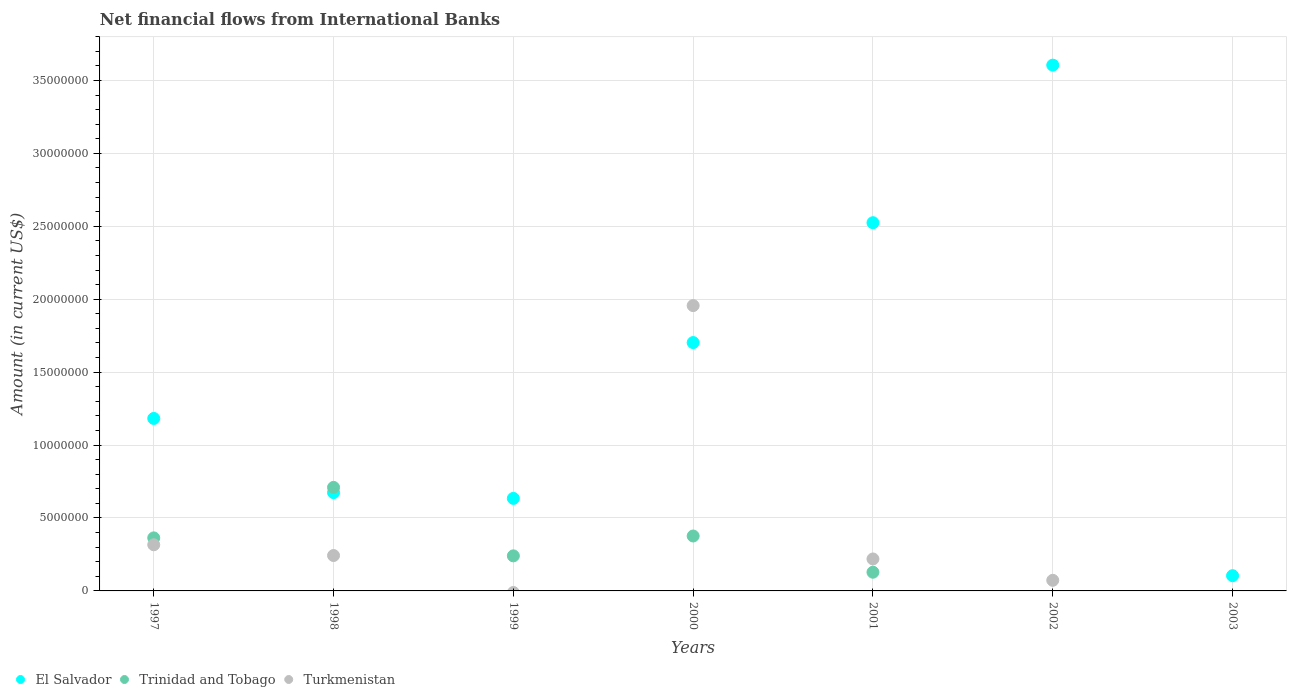Is the number of dotlines equal to the number of legend labels?
Keep it short and to the point. No. What is the net financial aid flows in Trinidad and Tobago in 1999?
Offer a terse response. 2.40e+06. Across all years, what is the maximum net financial aid flows in El Salvador?
Your response must be concise. 3.60e+07. In which year was the net financial aid flows in Trinidad and Tobago maximum?
Provide a succinct answer. 1998. What is the total net financial aid flows in Trinidad and Tobago in the graph?
Your answer should be very brief. 1.82e+07. What is the difference between the net financial aid flows in El Salvador in 2000 and that in 2003?
Your answer should be very brief. 1.60e+07. What is the difference between the net financial aid flows in Turkmenistan in 1999 and the net financial aid flows in Trinidad and Tobago in 2001?
Provide a succinct answer. -1.28e+06. What is the average net financial aid flows in Trinidad and Tobago per year?
Your answer should be very brief. 2.60e+06. In the year 1997, what is the difference between the net financial aid flows in El Salvador and net financial aid flows in Turkmenistan?
Ensure brevity in your answer.  8.66e+06. What is the ratio of the net financial aid flows in El Salvador in 2001 to that in 2003?
Your answer should be very brief. 24.18. Is the net financial aid flows in El Salvador in 1999 less than that in 2001?
Give a very brief answer. Yes. What is the difference between the highest and the second highest net financial aid flows in El Salvador?
Offer a very short reply. 1.08e+07. What is the difference between the highest and the lowest net financial aid flows in Turkmenistan?
Provide a short and direct response. 1.96e+07. In how many years, is the net financial aid flows in Turkmenistan greater than the average net financial aid flows in Turkmenistan taken over all years?
Your answer should be compact. 1. Where does the legend appear in the graph?
Give a very brief answer. Bottom left. How are the legend labels stacked?
Keep it short and to the point. Horizontal. What is the title of the graph?
Give a very brief answer. Net financial flows from International Banks. Does "Vanuatu" appear as one of the legend labels in the graph?
Your response must be concise. No. What is the label or title of the X-axis?
Your response must be concise. Years. What is the label or title of the Y-axis?
Give a very brief answer. Amount (in current US$). What is the Amount (in current US$) in El Salvador in 1997?
Provide a short and direct response. 1.18e+07. What is the Amount (in current US$) of Trinidad and Tobago in 1997?
Give a very brief answer. 3.64e+06. What is the Amount (in current US$) in Turkmenistan in 1997?
Your answer should be very brief. 3.16e+06. What is the Amount (in current US$) of El Salvador in 1998?
Offer a terse response. 6.74e+06. What is the Amount (in current US$) of Trinidad and Tobago in 1998?
Offer a terse response. 7.10e+06. What is the Amount (in current US$) in Turkmenistan in 1998?
Keep it short and to the point. 2.43e+06. What is the Amount (in current US$) of El Salvador in 1999?
Provide a short and direct response. 6.34e+06. What is the Amount (in current US$) in Trinidad and Tobago in 1999?
Your response must be concise. 2.40e+06. What is the Amount (in current US$) of Turkmenistan in 1999?
Offer a terse response. 0. What is the Amount (in current US$) in El Salvador in 2000?
Provide a short and direct response. 1.70e+07. What is the Amount (in current US$) in Trinidad and Tobago in 2000?
Keep it short and to the point. 3.76e+06. What is the Amount (in current US$) in Turkmenistan in 2000?
Provide a succinct answer. 1.96e+07. What is the Amount (in current US$) in El Salvador in 2001?
Ensure brevity in your answer.  2.52e+07. What is the Amount (in current US$) in Trinidad and Tobago in 2001?
Your answer should be very brief. 1.28e+06. What is the Amount (in current US$) of Turkmenistan in 2001?
Your response must be concise. 2.19e+06. What is the Amount (in current US$) in El Salvador in 2002?
Offer a very short reply. 3.60e+07. What is the Amount (in current US$) of Turkmenistan in 2002?
Make the answer very short. 7.27e+05. What is the Amount (in current US$) of El Salvador in 2003?
Your answer should be compact. 1.04e+06. What is the Amount (in current US$) of Trinidad and Tobago in 2003?
Offer a terse response. 0. What is the Amount (in current US$) of Turkmenistan in 2003?
Ensure brevity in your answer.  0. Across all years, what is the maximum Amount (in current US$) in El Salvador?
Offer a terse response. 3.60e+07. Across all years, what is the maximum Amount (in current US$) in Trinidad and Tobago?
Your answer should be very brief. 7.10e+06. Across all years, what is the maximum Amount (in current US$) of Turkmenistan?
Provide a succinct answer. 1.96e+07. Across all years, what is the minimum Amount (in current US$) in El Salvador?
Provide a succinct answer. 1.04e+06. Across all years, what is the minimum Amount (in current US$) in Turkmenistan?
Keep it short and to the point. 0. What is the total Amount (in current US$) of El Salvador in the graph?
Your response must be concise. 1.04e+08. What is the total Amount (in current US$) in Trinidad and Tobago in the graph?
Give a very brief answer. 1.82e+07. What is the total Amount (in current US$) in Turkmenistan in the graph?
Offer a terse response. 2.81e+07. What is the difference between the Amount (in current US$) of El Salvador in 1997 and that in 1998?
Your answer should be compact. 5.08e+06. What is the difference between the Amount (in current US$) in Trinidad and Tobago in 1997 and that in 1998?
Offer a terse response. -3.46e+06. What is the difference between the Amount (in current US$) in Turkmenistan in 1997 and that in 1998?
Keep it short and to the point. 7.37e+05. What is the difference between the Amount (in current US$) in El Salvador in 1997 and that in 1999?
Your answer should be very brief. 5.48e+06. What is the difference between the Amount (in current US$) of Trinidad and Tobago in 1997 and that in 1999?
Provide a short and direct response. 1.23e+06. What is the difference between the Amount (in current US$) in El Salvador in 1997 and that in 2000?
Make the answer very short. -5.20e+06. What is the difference between the Amount (in current US$) of Trinidad and Tobago in 1997 and that in 2000?
Your response must be concise. -1.28e+05. What is the difference between the Amount (in current US$) of Turkmenistan in 1997 and that in 2000?
Provide a short and direct response. -1.64e+07. What is the difference between the Amount (in current US$) of El Salvador in 1997 and that in 2001?
Provide a succinct answer. -1.34e+07. What is the difference between the Amount (in current US$) in Trinidad and Tobago in 1997 and that in 2001?
Offer a terse response. 2.35e+06. What is the difference between the Amount (in current US$) in Turkmenistan in 1997 and that in 2001?
Offer a terse response. 9.73e+05. What is the difference between the Amount (in current US$) of El Salvador in 1997 and that in 2002?
Give a very brief answer. -2.42e+07. What is the difference between the Amount (in current US$) of Turkmenistan in 1997 and that in 2002?
Offer a terse response. 2.44e+06. What is the difference between the Amount (in current US$) in El Salvador in 1997 and that in 2003?
Offer a terse response. 1.08e+07. What is the difference between the Amount (in current US$) of El Salvador in 1998 and that in 1999?
Offer a very short reply. 3.96e+05. What is the difference between the Amount (in current US$) of Trinidad and Tobago in 1998 and that in 1999?
Provide a succinct answer. 4.69e+06. What is the difference between the Amount (in current US$) in El Salvador in 1998 and that in 2000?
Offer a terse response. -1.03e+07. What is the difference between the Amount (in current US$) of Trinidad and Tobago in 1998 and that in 2000?
Your answer should be compact. 3.33e+06. What is the difference between the Amount (in current US$) in Turkmenistan in 1998 and that in 2000?
Provide a short and direct response. -1.71e+07. What is the difference between the Amount (in current US$) of El Salvador in 1998 and that in 2001?
Provide a succinct answer. -1.85e+07. What is the difference between the Amount (in current US$) in Trinidad and Tobago in 1998 and that in 2001?
Provide a succinct answer. 5.82e+06. What is the difference between the Amount (in current US$) in Turkmenistan in 1998 and that in 2001?
Offer a terse response. 2.36e+05. What is the difference between the Amount (in current US$) in El Salvador in 1998 and that in 2002?
Offer a terse response. -2.93e+07. What is the difference between the Amount (in current US$) of Turkmenistan in 1998 and that in 2002?
Offer a very short reply. 1.70e+06. What is the difference between the Amount (in current US$) in El Salvador in 1998 and that in 2003?
Ensure brevity in your answer.  5.70e+06. What is the difference between the Amount (in current US$) of El Salvador in 1999 and that in 2000?
Your answer should be compact. -1.07e+07. What is the difference between the Amount (in current US$) of Trinidad and Tobago in 1999 and that in 2000?
Provide a succinct answer. -1.36e+06. What is the difference between the Amount (in current US$) of El Salvador in 1999 and that in 2001?
Ensure brevity in your answer.  -1.89e+07. What is the difference between the Amount (in current US$) in Trinidad and Tobago in 1999 and that in 2001?
Offer a terse response. 1.12e+06. What is the difference between the Amount (in current US$) of El Salvador in 1999 and that in 2002?
Ensure brevity in your answer.  -2.97e+07. What is the difference between the Amount (in current US$) of El Salvador in 1999 and that in 2003?
Provide a succinct answer. 5.30e+06. What is the difference between the Amount (in current US$) of El Salvador in 2000 and that in 2001?
Make the answer very short. -8.22e+06. What is the difference between the Amount (in current US$) of Trinidad and Tobago in 2000 and that in 2001?
Make the answer very short. 2.48e+06. What is the difference between the Amount (in current US$) of Turkmenistan in 2000 and that in 2001?
Your response must be concise. 1.74e+07. What is the difference between the Amount (in current US$) in El Salvador in 2000 and that in 2002?
Your answer should be very brief. -1.90e+07. What is the difference between the Amount (in current US$) of Turkmenistan in 2000 and that in 2002?
Your answer should be very brief. 1.88e+07. What is the difference between the Amount (in current US$) of El Salvador in 2000 and that in 2003?
Offer a terse response. 1.60e+07. What is the difference between the Amount (in current US$) in El Salvador in 2001 and that in 2002?
Keep it short and to the point. -1.08e+07. What is the difference between the Amount (in current US$) in Turkmenistan in 2001 and that in 2002?
Ensure brevity in your answer.  1.46e+06. What is the difference between the Amount (in current US$) in El Salvador in 2001 and that in 2003?
Your answer should be compact. 2.42e+07. What is the difference between the Amount (in current US$) of El Salvador in 2002 and that in 2003?
Keep it short and to the point. 3.50e+07. What is the difference between the Amount (in current US$) of El Salvador in 1997 and the Amount (in current US$) of Trinidad and Tobago in 1998?
Offer a terse response. 4.73e+06. What is the difference between the Amount (in current US$) in El Salvador in 1997 and the Amount (in current US$) in Turkmenistan in 1998?
Provide a short and direct response. 9.40e+06. What is the difference between the Amount (in current US$) in Trinidad and Tobago in 1997 and the Amount (in current US$) in Turkmenistan in 1998?
Offer a terse response. 1.21e+06. What is the difference between the Amount (in current US$) of El Salvador in 1997 and the Amount (in current US$) of Trinidad and Tobago in 1999?
Your answer should be compact. 9.42e+06. What is the difference between the Amount (in current US$) of El Salvador in 1997 and the Amount (in current US$) of Trinidad and Tobago in 2000?
Offer a terse response. 8.06e+06. What is the difference between the Amount (in current US$) of El Salvador in 1997 and the Amount (in current US$) of Turkmenistan in 2000?
Make the answer very short. -7.74e+06. What is the difference between the Amount (in current US$) in Trinidad and Tobago in 1997 and the Amount (in current US$) in Turkmenistan in 2000?
Make the answer very short. -1.59e+07. What is the difference between the Amount (in current US$) in El Salvador in 1997 and the Amount (in current US$) in Trinidad and Tobago in 2001?
Keep it short and to the point. 1.05e+07. What is the difference between the Amount (in current US$) of El Salvador in 1997 and the Amount (in current US$) of Turkmenistan in 2001?
Provide a short and direct response. 9.63e+06. What is the difference between the Amount (in current US$) of Trinidad and Tobago in 1997 and the Amount (in current US$) of Turkmenistan in 2001?
Offer a very short reply. 1.45e+06. What is the difference between the Amount (in current US$) in El Salvador in 1997 and the Amount (in current US$) in Turkmenistan in 2002?
Provide a succinct answer. 1.11e+07. What is the difference between the Amount (in current US$) in Trinidad and Tobago in 1997 and the Amount (in current US$) in Turkmenistan in 2002?
Your answer should be very brief. 2.91e+06. What is the difference between the Amount (in current US$) of El Salvador in 1998 and the Amount (in current US$) of Trinidad and Tobago in 1999?
Give a very brief answer. 4.34e+06. What is the difference between the Amount (in current US$) of El Salvador in 1998 and the Amount (in current US$) of Trinidad and Tobago in 2000?
Offer a very short reply. 2.98e+06. What is the difference between the Amount (in current US$) in El Salvador in 1998 and the Amount (in current US$) in Turkmenistan in 2000?
Offer a very short reply. -1.28e+07. What is the difference between the Amount (in current US$) of Trinidad and Tobago in 1998 and the Amount (in current US$) of Turkmenistan in 2000?
Your answer should be very brief. -1.25e+07. What is the difference between the Amount (in current US$) of El Salvador in 1998 and the Amount (in current US$) of Trinidad and Tobago in 2001?
Make the answer very short. 5.46e+06. What is the difference between the Amount (in current US$) in El Salvador in 1998 and the Amount (in current US$) in Turkmenistan in 2001?
Your answer should be compact. 4.55e+06. What is the difference between the Amount (in current US$) in Trinidad and Tobago in 1998 and the Amount (in current US$) in Turkmenistan in 2001?
Provide a succinct answer. 4.91e+06. What is the difference between the Amount (in current US$) of El Salvador in 1998 and the Amount (in current US$) of Turkmenistan in 2002?
Ensure brevity in your answer.  6.01e+06. What is the difference between the Amount (in current US$) in Trinidad and Tobago in 1998 and the Amount (in current US$) in Turkmenistan in 2002?
Give a very brief answer. 6.37e+06. What is the difference between the Amount (in current US$) in El Salvador in 1999 and the Amount (in current US$) in Trinidad and Tobago in 2000?
Keep it short and to the point. 2.58e+06. What is the difference between the Amount (in current US$) in El Salvador in 1999 and the Amount (in current US$) in Turkmenistan in 2000?
Ensure brevity in your answer.  -1.32e+07. What is the difference between the Amount (in current US$) of Trinidad and Tobago in 1999 and the Amount (in current US$) of Turkmenistan in 2000?
Offer a terse response. -1.72e+07. What is the difference between the Amount (in current US$) in El Salvador in 1999 and the Amount (in current US$) in Trinidad and Tobago in 2001?
Your response must be concise. 5.06e+06. What is the difference between the Amount (in current US$) of El Salvador in 1999 and the Amount (in current US$) of Turkmenistan in 2001?
Ensure brevity in your answer.  4.15e+06. What is the difference between the Amount (in current US$) of Trinidad and Tobago in 1999 and the Amount (in current US$) of Turkmenistan in 2001?
Ensure brevity in your answer.  2.12e+05. What is the difference between the Amount (in current US$) in El Salvador in 1999 and the Amount (in current US$) in Turkmenistan in 2002?
Provide a short and direct response. 5.62e+06. What is the difference between the Amount (in current US$) of Trinidad and Tobago in 1999 and the Amount (in current US$) of Turkmenistan in 2002?
Ensure brevity in your answer.  1.68e+06. What is the difference between the Amount (in current US$) in El Salvador in 2000 and the Amount (in current US$) in Trinidad and Tobago in 2001?
Make the answer very short. 1.57e+07. What is the difference between the Amount (in current US$) of El Salvador in 2000 and the Amount (in current US$) of Turkmenistan in 2001?
Your answer should be very brief. 1.48e+07. What is the difference between the Amount (in current US$) of Trinidad and Tobago in 2000 and the Amount (in current US$) of Turkmenistan in 2001?
Offer a very short reply. 1.57e+06. What is the difference between the Amount (in current US$) of El Salvador in 2000 and the Amount (in current US$) of Turkmenistan in 2002?
Your answer should be compact. 1.63e+07. What is the difference between the Amount (in current US$) in Trinidad and Tobago in 2000 and the Amount (in current US$) in Turkmenistan in 2002?
Provide a succinct answer. 3.04e+06. What is the difference between the Amount (in current US$) in El Salvador in 2001 and the Amount (in current US$) in Turkmenistan in 2002?
Your answer should be very brief. 2.45e+07. What is the difference between the Amount (in current US$) in Trinidad and Tobago in 2001 and the Amount (in current US$) in Turkmenistan in 2002?
Keep it short and to the point. 5.55e+05. What is the average Amount (in current US$) in El Salvador per year?
Ensure brevity in your answer.  1.49e+07. What is the average Amount (in current US$) of Trinidad and Tobago per year?
Your answer should be compact. 2.60e+06. What is the average Amount (in current US$) of Turkmenistan per year?
Your answer should be compact. 4.01e+06. In the year 1997, what is the difference between the Amount (in current US$) in El Salvador and Amount (in current US$) in Trinidad and Tobago?
Make the answer very short. 8.19e+06. In the year 1997, what is the difference between the Amount (in current US$) in El Salvador and Amount (in current US$) in Turkmenistan?
Offer a very short reply. 8.66e+06. In the year 1997, what is the difference between the Amount (in current US$) of Trinidad and Tobago and Amount (in current US$) of Turkmenistan?
Offer a terse response. 4.73e+05. In the year 1998, what is the difference between the Amount (in current US$) of El Salvador and Amount (in current US$) of Trinidad and Tobago?
Ensure brevity in your answer.  -3.58e+05. In the year 1998, what is the difference between the Amount (in current US$) in El Salvador and Amount (in current US$) in Turkmenistan?
Offer a terse response. 4.31e+06. In the year 1998, what is the difference between the Amount (in current US$) of Trinidad and Tobago and Amount (in current US$) of Turkmenistan?
Ensure brevity in your answer.  4.67e+06. In the year 1999, what is the difference between the Amount (in current US$) in El Salvador and Amount (in current US$) in Trinidad and Tobago?
Your answer should be very brief. 3.94e+06. In the year 2000, what is the difference between the Amount (in current US$) in El Salvador and Amount (in current US$) in Trinidad and Tobago?
Your response must be concise. 1.33e+07. In the year 2000, what is the difference between the Amount (in current US$) in El Salvador and Amount (in current US$) in Turkmenistan?
Offer a very short reply. -2.54e+06. In the year 2000, what is the difference between the Amount (in current US$) of Trinidad and Tobago and Amount (in current US$) of Turkmenistan?
Your response must be concise. -1.58e+07. In the year 2001, what is the difference between the Amount (in current US$) in El Salvador and Amount (in current US$) in Trinidad and Tobago?
Your answer should be compact. 2.40e+07. In the year 2001, what is the difference between the Amount (in current US$) in El Salvador and Amount (in current US$) in Turkmenistan?
Offer a terse response. 2.31e+07. In the year 2001, what is the difference between the Amount (in current US$) of Trinidad and Tobago and Amount (in current US$) of Turkmenistan?
Make the answer very short. -9.09e+05. In the year 2002, what is the difference between the Amount (in current US$) in El Salvador and Amount (in current US$) in Turkmenistan?
Your response must be concise. 3.53e+07. What is the ratio of the Amount (in current US$) in El Salvador in 1997 to that in 1998?
Your answer should be very brief. 1.75. What is the ratio of the Amount (in current US$) in Trinidad and Tobago in 1997 to that in 1998?
Your response must be concise. 0.51. What is the ratio of the Amount (in current US$) in Turkmenistan in 1997 to that in 1998?
Offer a terse response. 1.3. What is the ratio of the Amount (in current US$) in El Salvador in 1997 to that in 1999?
Provide a short and direct response. 1.86. What is the ratio of the Amount (in current US$) of Trinidad and Tobago in 1997 to that in 1999?
Give a very brief answer. 1.51. What is the ratio of the Amount (in current US$) of El Salvador in 1997 to that in 2000?
Offer a terse response. 0.69. What is the ratio of the Amount (in current US$) of Trinidad and Tobago in 1997 to that in 2000?
Your response must be concise. 0.97. What is the ratio of the Amount (in current US$) in Turkmenistan in 1997 to that in 2000?
Your answer should be compact. 0.16. What is the ratio of the Amount (in current US$) in El Salvador in 1997 to that in 2001?
Provide a short and direct response. 0.47. What is the ratio of the Amount (in current US$) of Trinidad and Tobago in 1997 to that in 2001?
Provide a succinct answer. 2.84. What is the ratio of the Amount (in current US$) in Turkmenistan in 1997 to that in 2001?
Provide a short and direct response. 1.44. What is the ratio of the Amount (in current US$) in El Salvador in 1997 to that in 2002?
Keep it short and to the point. 0.33. What is the ratio of the Amount (in current US$) of Turkmenistan in 1997 to that in 2002?
Give a very brief answer. 4.35. What is the ratio of the Amount (in current US$) in El Salvador in 1997 to that in 2003?
Give a very brief answer. 11.33. What is the ratio of the Amount (in current US$) of El Salvador in 1998 to that in 1999?
Keep it short and to the point. 1.06. What is the ratio of the Amount (in current US$) in Trinidad and Tobago in 1998 to that in 1999?
Provide a short and direct response. 2.95. What is the ratio of the Amount (in current US$) of El Salvador in 1998 to that in 2000?
Your answer should be very brief. 0.4. What is the ratio of the Amount (in current US$) in Trinidad and Tobago in 1998 to that in 2000?
Provide a succinct answer. 1.89. What is the ratio of the Amount (in current US$) in Turkmenistan in 1998 to that in 2000?
Give a very brief answer. 0.12. What is the ratio of the Amount (in current US$) of El Salvador in 1998 to that in 2001?
Make the answer very short. 0.27. What is the ratio of the Amount (in current US$) in Trinidad and Tobago in 1998 to that in 2001?
Provide a short and direct response. 5.54. What is the ratio of the Amount (in current US$) of Turkmenistan in 1998 to that in 2001?
Your answer should be very brief. 1.11. What is the ratio of the Amount (in current US$) in El Salvador in 1998 to that in 2002?
Your answer should be very brief. 0.19. What is the ratio of the Amount (in current US$) of Turkmenistan in 1998 to that in 2002?
Keep it short and to the point. 3.34. What is the ratio of the Amount (in current US$) in El Salvador in 1998 to that in 2003?
Provide a succinct answer. 6.46. What is the ratio of the Amount (in current US$) in El Salvador in 1999 to that in 2000?
Ensure brevity in your answer.  0.37. What is the ratio of the Amount (in current US$) of Trinidad and Tobago in 1999 to that in 2000?
Ensure brevity in your answer.  0.64. What is the ratio of the Amount (in current US$) of El Salvador in 1999 to that in 2001?
Your answer should be very brief. 0.25. What is the ratio of the Amount (in current US$) of Trinidad and Tobago in 1999 to that in 2001?
Your answer should be very brief. 1.87. What is the ratio of the Amount (in current US$) of El Salvador in 1999 to that in 2002?
Give a very brief answer. 0.18. What is the ratio of the Amount (in current US$) of El Salvador in 1999 to that in 2003?
Provide a short and direct response. 6.08. What is the ratio of the Amount (in current US$) of El Salvador in 2000 to that in 2001?
Your answer should be compact. 0.67. What is the ratio of the Amount (in current US$) in Trinidad and Tobago in 2000 to that in 2001?
Provide a short and direct response. 2.94. What is the ratio of the Amount (in current US$) of Turkmenistan in 2000 to that in 2001?
Provide a short and direct response. 8.93. What is the ratio of the Amount (in current US$) of El Salvador in 2000 to that in 2002?
Your answer should be very brief. 0.47. What is the ratio of the Amount (in current US$) in Turkmenistan in 2000 to that in 2002?
Your response must be concise. 26.91. What is the ratio of the Amount (in current US$) in El Salvador in 2000 to that in 2003?
Provide a short and direct response. 16.31. What is the ratio of the Amount (in current US$) in El Salvador in 2001 to that in 2002?
Give a very brief answer. 0.7. What is the ratio of the Amount (in current US$) in Turkmenistan in 2001 to that in 2002?
Give a very brief answer. 3.01. What is the ratio of the Amount (in current US$) in El Salvador in 2001 to that in 2003?
Ensure brevity in your answer.  24.18. What is the ratio of the Amount (in current US$) in El Salvador in 2002 to that in 2003?
Ensure brevity in your answer.  34.53. What is the difference between the highest and the second highest Amount (in current US$) in El Salvador?
Provide a short and direct response. 1.08e+07. What is the difference between the highest and the second highest Amount (in current US$) of Trinidad and Tobago?
Provide a short and direct response. 3.33e+06. What is the difference between the highest and the second highest Amount (in current US$) of Turkmenistan?
Provide a succinct answer. 1.64e+07. What is the difference between the highest and the lowest Amount (in current US$) in El Salvador?
Provide a short and direct response. 3.50e+07. What is the difference between the highest and the lowest Amount (in current US$) in Trinidad and Tobago?
Make the answer very short. 7.10e+06. What is the difference between the highest and the lowest Amount (in current US$) in Turkmenistan?
Keep it short and to the point. 1.96e+07. 